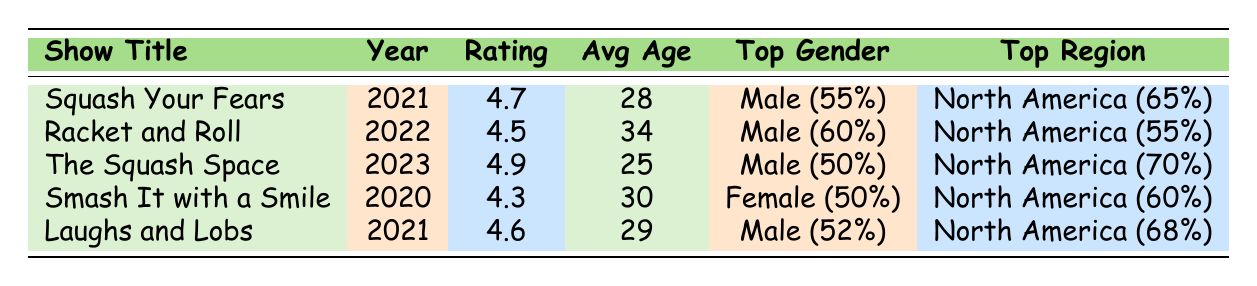What is the highest rating among the shows? The highest rating in the table is 4.9, which belongs to "The Squash Space."
Answer: 4.9 Which show has the youngest average audience? The show with the youngest average audience is "The Squash Space," with an average age of 25.
Answer: 25 What percentage of viewers of "Squash Your Fears" are from Europe? In "Squash Your Fears," 20% of viewers are from Europe, as indicated in the geographic distribution.
Answer: 20% Is the majority of the audience male for "Smash It with a Smile"? For "Smash It with a Smile," the gender distribution shows that 50% of viewers are female, meaning there is no male majority.
Answer: No What is the average age of viewers across all shows? To find the average age, we sum the average ages: (28 + 34 + 25 + 30 + 29) = 146. The number of shows is 5, so the average age is 146/5 = 29.2.
Answer: 29.2 Which show had the highest percentage of non-binary viewers? Analyzing the gender distribution, all shows have 5% non-binary viewers except "Smash It with a Smile," which has 5%. This means there is no show with a higher percentage.
Answer: No higher percentage What is the common interest shared by all shows? Reviewing the common interests for each show, "Stand-up Comedy" is featured in both "Squash Your Fears" and "The Squash Space," indicating it is a shared interest.
Answer: No common interest among all Which show had the oldest average audience? "Racket and Roll" had the oldest average audience, with an average age of 34, compared to the others.
Answer: 34 How many shows have a rating of 4.5 or higher? There are four shows with ratings of 4.5 or higher: "Squash Your Fears" (4.7), "Racket and Roll" (4.5), "The Squash Space" (4.9), and "Laughs and Lobs" (4.6). Summing these gives us a total of four shows.
Answer: 4 